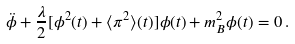<formula> <loc_0><loc_0><loc_500><loc_500>\ddot { \phi } + \frac { \lambda } { 2 } [ \phi ^ { 2 } ( t ) + \langle \pi ^ { 2 } \rangle ( t ) ] \phi ( t ) + m _ { B } ^ { 2 } \phi ( t ) = 0 \, .</formula> 